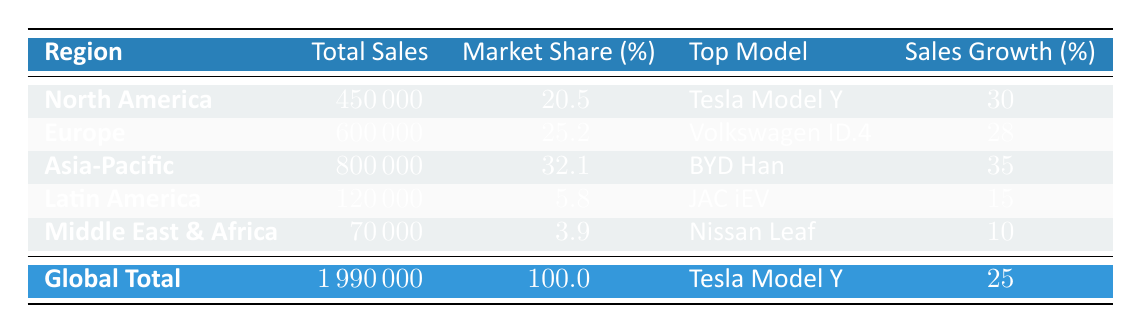What is the total sales of electric vehicles in Europe? The table lists total sales of electric vehicles in the Europe region as 600,000 units.
Answer: 600000 Which region has the highest market share for electric vehicles? The data shows that Asia-Pacific has the highest market share at 32.1%.
Answer: Asia-Pacific What is the top model sold in North America? According to the table, the top model sold in North America is the Tesla Model Y.
Answer: Tesla Model Y How much did sales grow in the Asia-Pacific region? The table indicates that sales growth in the Asia-Pacific region was 35%.
Answer: 35 Which region had the lowest total sales? By comparing the total sales values, Middle East & Africa has the lowest total sales at 70,000 units.
Answer: Middle East & Africa What is the combined total sales of North America and Latin America? Total sales of North America is 450,000, and for Latin America, it is 120,000. Adding them gives (450,000 + 120,000) = 570,000.
Answer: 570000 Is the Tesla Model Y the top model globally for electric vehicle sales in 2023? The global total data states that the Tesla Model Y is listed as the top model sold, confirming it is the top model globally.
Answer: Yes What is the difference in total sales between Europe and Latin America? Total sales for Europe is 600,000, and for Latin America is 120,000. The difference is (600,000 - 120,000) = 480,000.
Answer: 480000 By how much did the sales grow in Latin America compared to the sales growth in the Middle East & Africa? Sales growth in Latin America is 15%, and in the Middle East & Africa is 10%. The difference in growth is (15 - 10) = 5 percentage points.
Answer: 5 What is the average market share of electric vehicle sales across all regions? The sum of market shares is (20.5 + 25.2 + 32.1 + 5.8 + 3.9) = 87.5, divided by 5 regions gives an average of 87.5 / 5 = 17.5%.
Answer: 17.5 